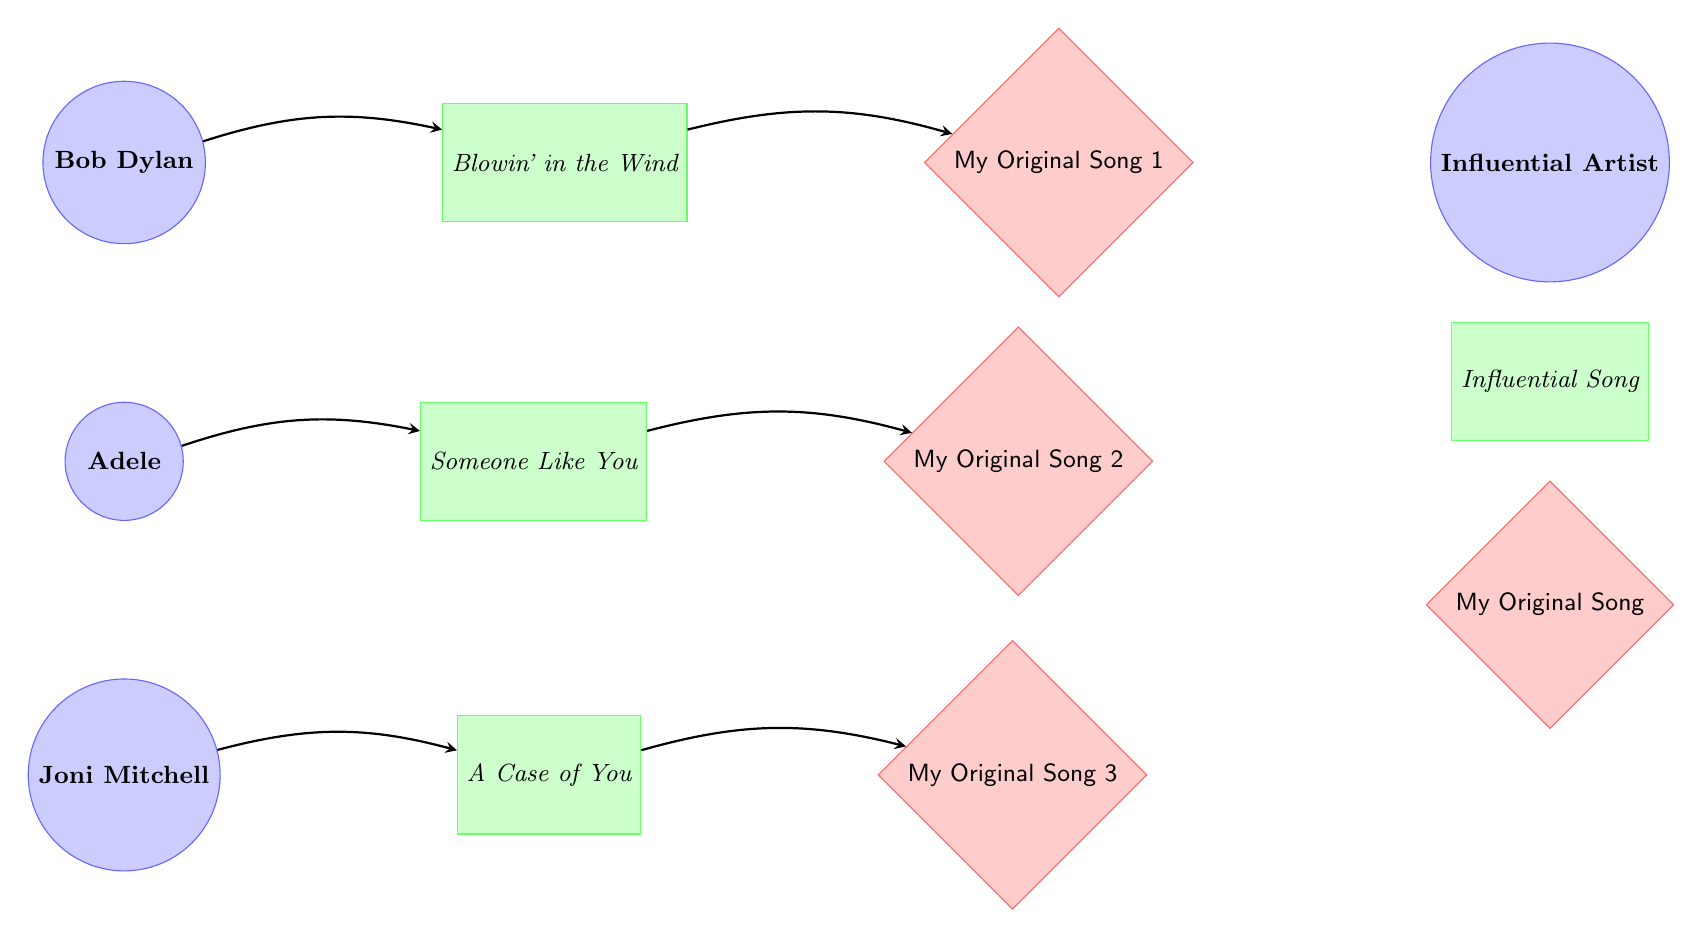What is the first influential song listed in the diagram? The diagram shows that the first influential song listed next to Bob Dylan is "Blowin' in the Wind."
Answer: Blowin' in the Wind How many original songs are represented in the diagram? In the diagram, there are three original songs represented as nodes: "My Original Song 1," "My Original Song 2," and "My Original Song 3."
Answer: 3 Who is the influential artist connected to "Someone Like You"? The diagram shows that "Someone Like You" is connected to the influential artist Adele.
Answer: Adele Which influential song is associated with My Original Song 2? The diagram indicates that "My Original Song 2" is associated with the influential song "Someone Like You," as represented by the arrow connection.
Answer: Someone Like You What is the relationship between Joni Mitchell and My Original Song 3? Joni Mitchell is connected through the song "A Case of You," which leads to "My Original Song 3" as seen in the diagram.
Answer: A Case of You How many total influential artists are shown in the diagram? The diagram clearly presents three influential artists: Bob Dylan, Adele, and Joni Mitchell.
Answer: 3 Which song directly influences My Original Song 1? The diagram states that "Blowin' in the Wind" directly influences "My Original Song 1."
Answer: Blowin' in the Wind What type of node is "A Case of You"? "A Case of You" is categorized as a song node in the diagram, indicated by its rectangular shape.
Answer: song What connection type exists between Bob Dylan and My Original Song 1? The connection between Bob Dylan and "My Original Song 1" is an arrow, representing an influence relationship.
Answer: influence 